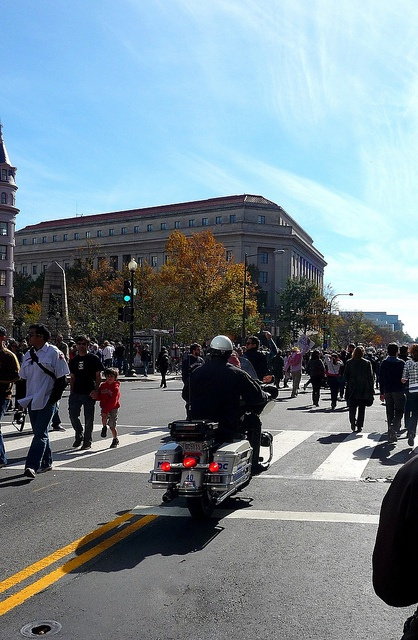Describe the objects in this image and their specific colors. I can see motorcycle in lightblue, black, gray, darkgray, and lightgray tones, people in lightblue, black, gray, darkgray, and lightgray tones, people in lightblue, black, darkgray, lightgray, and gray tones, people in lightblue, black, darkgray, gray, and lightgray tones, and people in lightblue, black, gray, and navy tones in this image. 